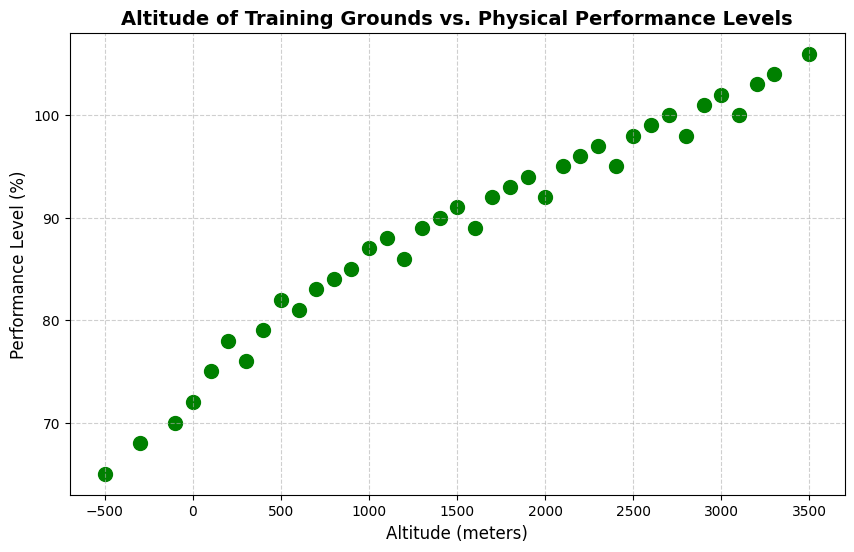What's the altitude that corresponds to the highest performance level? By looking at the scatter plot, the highest performance level is at 106%, which corresponds to an altitude of 3500 meters.
Answer: 3500 meters At what altitude does the performance level first reach above 90%? The scatter plot indicates the performance level reaches 91% at 1500 meters.
Answer: 1500 meters Between what two altitudes is there a significant increase in performance levels around the 100% mark? Observing the scatter plot, there is a noticeable increase in performance levels between 2900 meters (101%) and 3100 meters (103%).
Answer: 2900 meters and 3100 meters Which altitude corresponds to a performance level that does not follow the general trend of performance increasing with altitude? At 200 meters, the performance level decreases from 78% to 76%, which does not follow the increasing trend.
Answer: 300 meters Is there any point where the performance level decreases as altitude increases? If so, where? Yes, the performance level decreases from 82% to 81% between 500 meters and 600 meters.
Answer: Between 500 meters and 600 meters At what altitude does the performance level first reach 100%? The scatter plot shows that the performance level reaches 100% at 2700 meters.
Answer: 2700 meters What is the average performance level at altitudes above 2000 meters? Calculating the average for altitudes above 2000 meters, the corresponding performance levels are (92+95+96+97+95+98+99+98+101+102+100+103+104+106)/14 ≈ 98.
Answer: 98 Compare the performance levels at -500 meters and 3500 meters. At -500 meters, the performance level is 65%, while at 3500 meters, it is 106%. This shows a significant increase.
Answer: 65% at -500 meters and 106% at 3500 meters Are there any altitudes where the performance level remains constant? Yes, the performance level remains constant at 98% between 2800 meters and 2900 meters.
Answer: Between 2800 meters and 2900 meters What is the difference in performance levels between the lowest and highest altitudes? The lowest altitude is -500 meters with a performance level of 65%, and the highest altitude is 3500 meters with a performance level of 106%. The difference is 106% - 65% = 41%.
Answer: 41% 